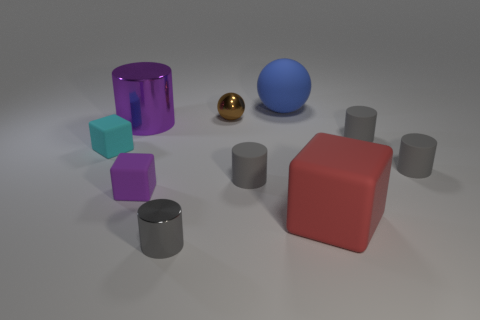There is a tiny matte cylinder left of the large blue rubber sphere; is its color the same as the tiny metallic cylinder?
Provide a short and direct response. Yes. What is the size of the other object that is the same shape as the small brown metal thing?
Ensure brevity in your answer.  Large. Is there any other thing that has the same shape as the blue matte object?
Provide a succinct answer. Yes. Do the tiny metallic object that is in front of the brown metal object and the matte cylinder to the left of the red rubber block have the same color?
Your answer should be compact. Yes. There is a brown metal object; is its size the same as the cylinder in front of the red object?
Give a very brief answer. Yes. Are the large object on the left side of the big blue sphere and the tiny thing behind the large purple thing made of the same material?
Offer a terse response. Yes. Is the number of big objects in front of the large block the same as the number of gray rubber objects on the right side of the small brown ball?
Offer a terse response. No. What number of other spheres are the same color as the big ball?
Offer a very short reply. 0. How many metallic things are purple cylinders or blue spheres?
Your answer should be very brief. 1. There is a tiny metal thing that is on the right side of the tiny metallic cylinder; is it the same shape as the big object behind the big purple object?
Keep it short and to the point. Yes. 